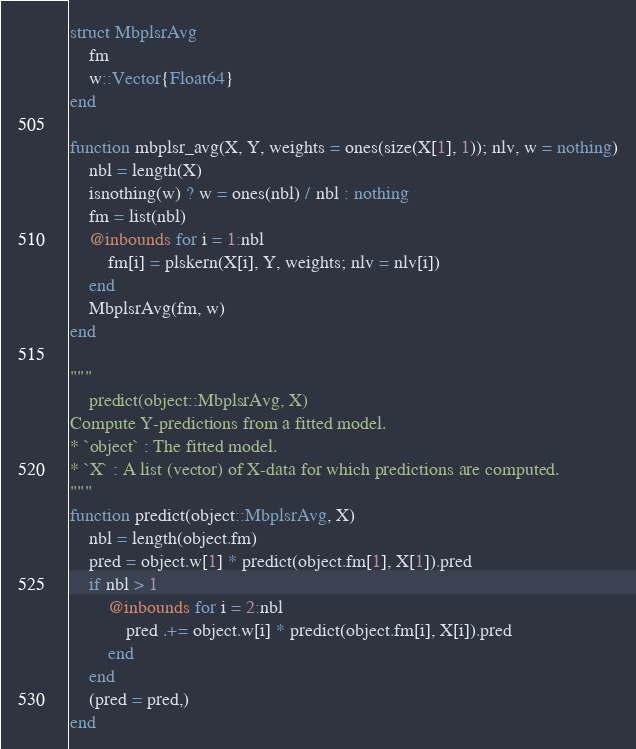Convert code to text. <code><loc_0><loc_0><loc_500><loc_500><_Julia_>struct MbplsrAvg
    fm
    w::Vector{Float64}
end

function mbplsr_avg(X, Y, weights = ones(size(X[1], 1)); nlv, w = nothing)
    nbl = length(X)
    isnothing(w) ? w = ones(nbl) / nbl : nothing
    fm = list(nbl)
    @inbounds for i = 1:nbl
        fm[i] = plskern(X[i], Y, weights; nlv = nlv[i])
    end
    MbplsrAvg(fm, w)
end

"""
    predict(object::MbplsrAvg, X)
Compute Y-predictions from a fitted model.
* `object` : The fitted model.
* `X` : A list (vector) of X-data for which predictions are computed.
""" 
function predict(object::MbplsrAvg, X)
    nbl = length(object.fm)
    pred = object.w[1] * predict(object.fm[1], X[1]).pred
    if nbl > 1
        @inbounds for i = 2:nbl
            pred .+= object.w[i] * predict(object.fm[i], X[i]).pred
        end
    end 
    (pred = pred,)
end

</code> 